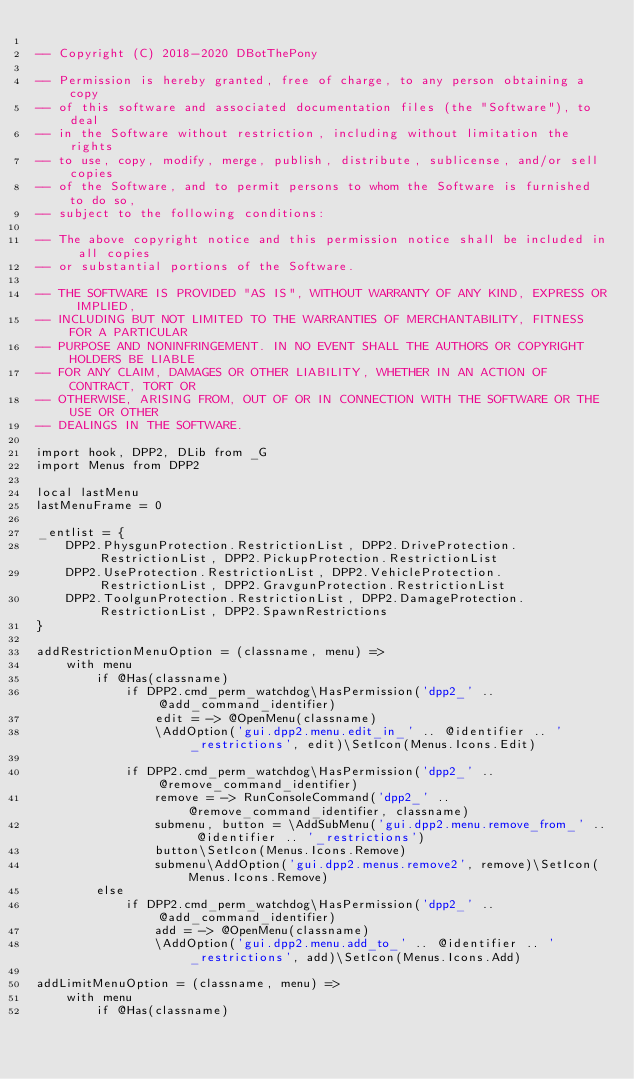<code> <loc_0><loc_0><loc_500><loc_500><_MoonScript_>
-- Copyright (C) 2018-2020 DBotThePony

-- Permission is hereby granted, free of charge, to any person obtaining a copy
-- of this software and associated documentation files (the "Software"), to deal
-- in the Software without restriction, including without limitation the rights
-- to use, copy, modify, merge, publish, distribute, sublicense, and/or sell copies
-- of the Software, and to permit persons to whom the Software is furnished to do so,
-- subject to the following conditions:

-- The above copyright notice and this permission notice shall be included in all copies
-- or substantial portions of the Software.

-- THE SOFTWARE IS PROVIDED "AS IS", WITHOUT WARRANTY OF ANY KIND, EXPRESS OR IMPLIED,
-- INCLUDING BUT NOT LIMITED TO THE WARRANTIES OF MERCHANTABILITY, FITNESS FOR A PARTICULAR
-- PURPOSE AND NONINFRINGEMENT. IN NO EVENT SHALL THE AUTHORS OR COPYRIGHT HOLDERS BE LIABLE
-- FOR ANY CLAIM, DAMAGES OR OTHER LIABILITY, WHETHER IN AN ACTION OF CONTRACT, TORT OR
-- OTHERWISE, ARISING FROM, OUT OF OR IN CONNECTION WITH THE SOFTWARE OR THE USE OR OTHER
-- DEALINGS IN THE SOFTWARE.

import hook, DPP2, DLib from _G
import Menus from DPP2

local lastMenu
lastMenuFrame = 0

_entlist = {
	DPP2.PhysgunProtection.RestrictionList, DPP2.DriveProtection.RestrictionList, DPP2.PickupProtection.RestrictionList
	DPP2.UseProtection.RestrictionList, DPP2.VehicleProtection.RestrictionList, DPP2.GravgunProtection.RestrictionList
	DPP2.ToolgunProtection.RestrictionList, DPP2.DamageProtection.RestrictionList, DPP2.SpawnRestrictions
}

addRestrictionMenuOption = (classname, menu) =>
	with menu
		if @Has(classname)
			if DPP2.cmd_perm_watchdog\HasPermission('dpp2_' .. @add_command_identifier)
				edit = -> @OpenMenu(classname)
				\AddOption('gui.dpp2.menu.edit_in_' .. @identifier .. '_restrictions', edit)\SetIcon(Menus.Icons.Edit)

			if DPP2.cmd_perm_watchdog\HasPermission('dpp2_' .. @remove_command_identifier)
				remove = -> RunConsoleCommand('dpp2_' .. @remove_command_identifier, classname)
				submenu, button = \AddSubMenu('gui.dpp2.menu.remove_from_' .. @identifier .. '_restrictions')
				button\SetIcon(Menus.Icons.Remove)
				submenu\AddOption('gui.dpp2.menus.remove2', remove)\SetIcon(Menus.Icons.Remove)
		else
			if DPP2.cmd_perm_watchdog\HasPermission('dpp2_' .. @add_command_identifier)
				add = -> @OpenMenu(classname)
				\AddOption('gui.dpp2.menu.add_to_' .. @identifier .. '_restrictions', add)\SetIcon(Menus.Icons.Add)

addLimitMenuOption = (classname, menu) =>
	with menu
		if @Has(classname)</code> 